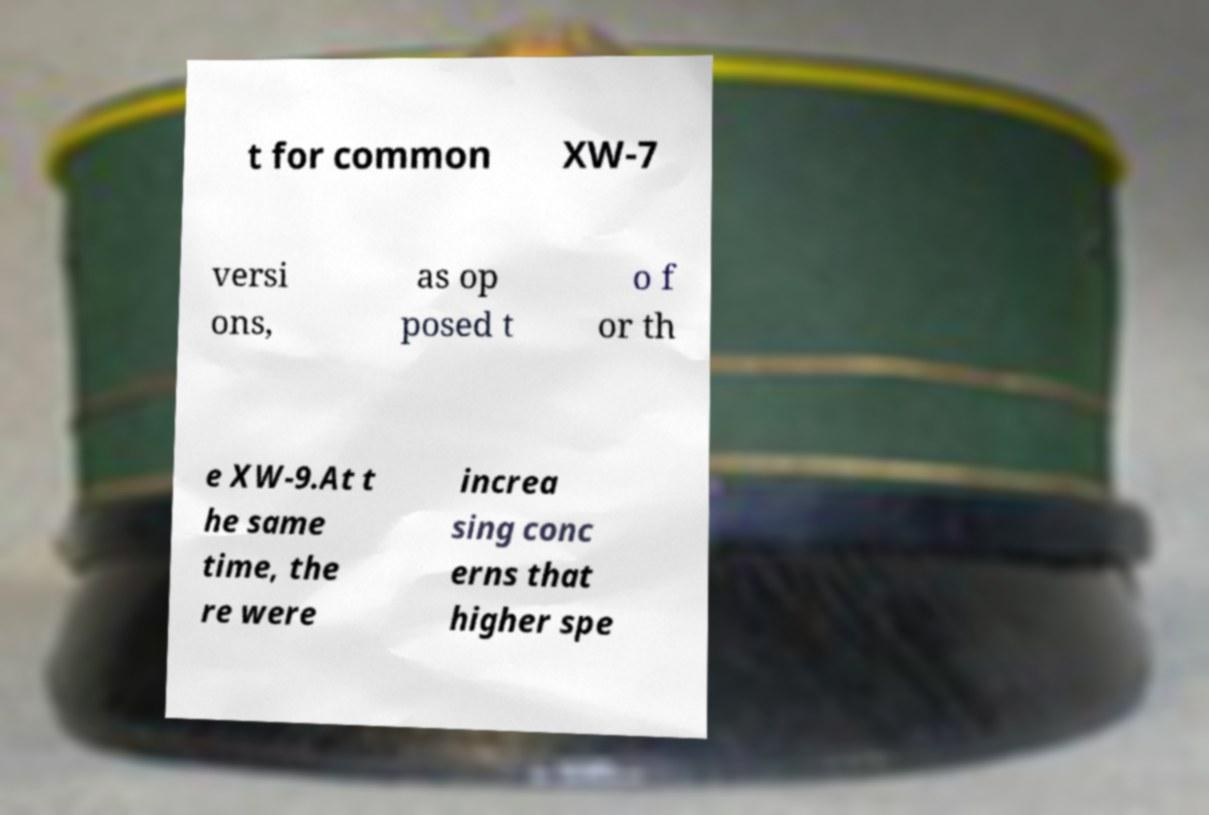What messages or text are displayed in this image? I need them in a readable, typed format. t for common XW-7 versi ons, as op posed t o f or th e XW-9.At t he same time, the re were increa sing conc erns that higher spe 